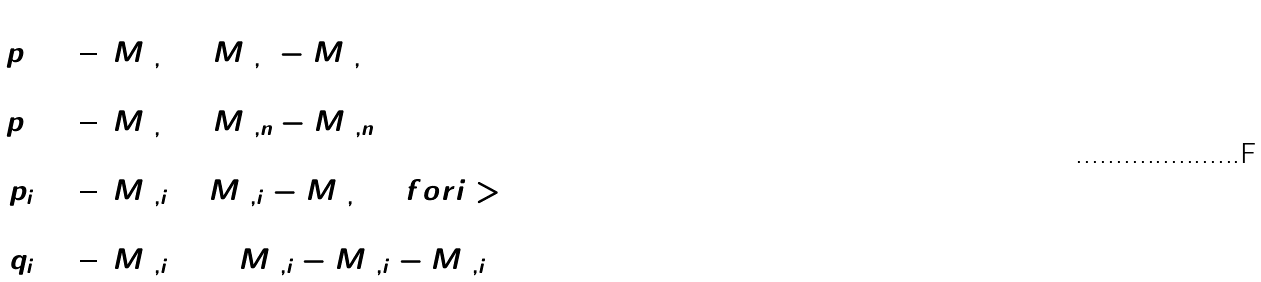Convert formula to latex. <formula><loc_0><loc_0><loc_500><loc_500>p _ { 1 } & = \frac { 1 } { 2 } ( M _ { 1 , 2 } + M _ { 1 , 3 } - M _ { 2 , 3 } ) \\ p _ { 2 } & = \frac { 1 } { 2 } ( M _ { 1 , 2 } + M _ { 2 , n } - M _ { 1 , n } ) \\ p _ { i } & = \frac { 1 } { 2 } ( M _ { 1 , i } + M _ { 2 , i } - M _ { 1 , 2 } ) \quad f o r i > 2 \\ q _ { i } & = \frac { 1 } { 2 } ( M _ { 1 , i + 1 } + M _ { 2 , i } - M _ { 1 , i } - M _ { 2 , i } )</formula> 